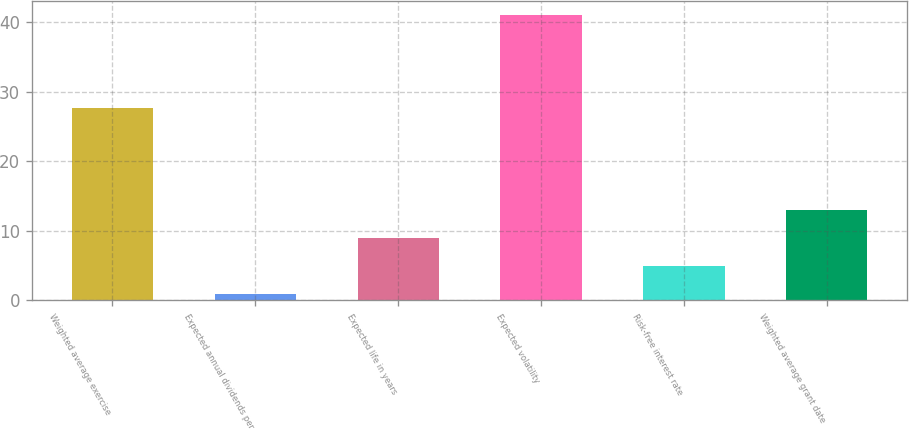Convert chart. <chart><loc_0><loc_0><loc_500><loc_500><bar_chart><fcel>Weighted average exercise<fcel>Expected annual dividends per<fcel>Expected life in years<fcel>Expected volatility<fcel>Risk-free interest rate<fcel>Weighted average grant date<nl><fcel>27.62<fcel>0.96<fcel>8.96<fcel>41<fcel>4.96<fcel>12.96<nl></chart> 